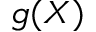Convert formula to latex. <formula><loc_0><loc_0><loc_500><loc_500>g ( X )</formula> 